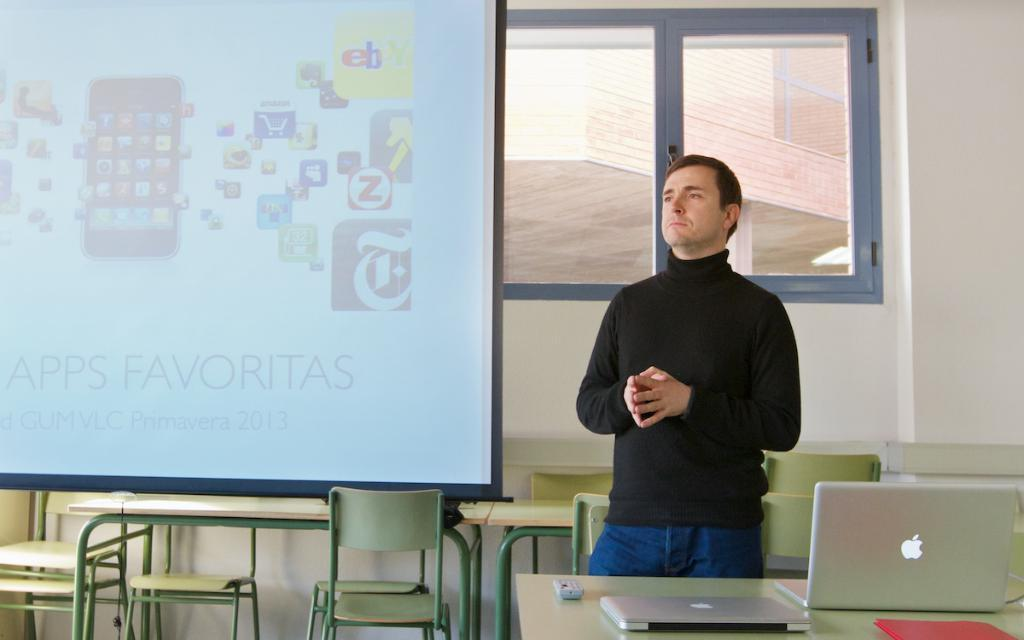What is the man in the image doing? The man is standing in the image. What object is in front of the man? The man has a laptop in front of him. What can be seen in the background of the image? There is a projector screen in the background of the image. Where is the nest located in the image? There is no nest present in the image. What type of plantation can be seen in the background of the image? There is no plantation present in the image; it features a projector screen in the background. 